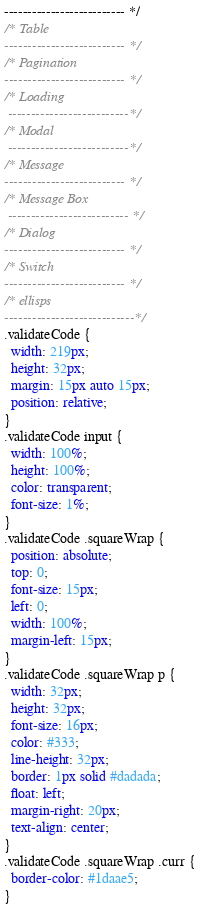<code> <loc_0><loc_0><loc_500><loc_500><_CSS_>-------------------------- */
/* Table
-------------------------- */
/* Pagination
-------------------------- */
/* Loading
 --------------------------*/
/* Modal
 --------------------------*/
/* Message
-------------------------- */
/* Message Box
 -------------------------- */
/* Dialog
-------------------------- */
/* Switch
-------------------------- */
/* ellisps
----------------------------*/
.validateCode {
  width: 219px;
  height: 32px;
  margin: 15px auto 15px;
  position: relative;
}
.validateCode input {
  width: 100%;
  height: 100%;
  color: transparent;
  font-size: 1%;
}
.validateCode .squareWrap {
  position: absolute;
  top: 0;
  font-size: 15px;
  left: 0;
  width: 100%;
  margin-left: 15px;
}
.validateCode .squareWrap p {
  width: 32px;
  height: 32px;
  font-size: 16px;
  color: #333;
  line-height: 32px;
  border: 1px solid #dadada;
  float: left;
  margin-right: 20px;
  text-align: center;
}
.validateCode .squareWrap .curr {
  border-color: #1daae5;
}
</code> 